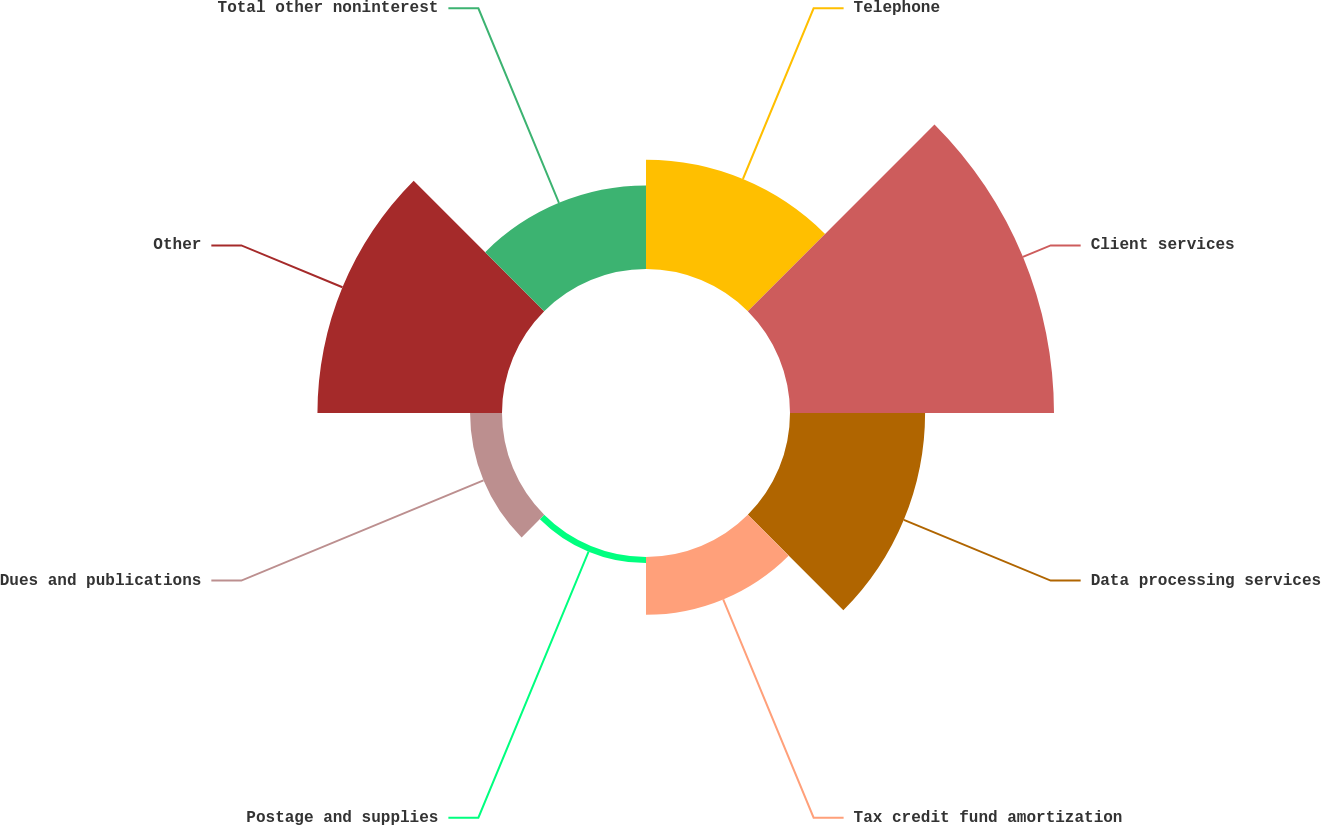Convert chart to OTSL. <chart><loc_0><loc_0><loc_500><loc_500><pie_chart><fcel>Telephone<fcel>Client services<fcel>Data processing services<fcel>Tax credit fund amortization<fcel>Postage and supplies<fcel>Dues and publications<fcel>Other<fcel>Total other noninterest<nl><fcel>12.53%<fcel>30.27%<fcel>15.49%<fcel>6.62%<fcel>0.7%<fcel>3.66%<fcel>21.16%<fcel>9.57%<nl></chart> 